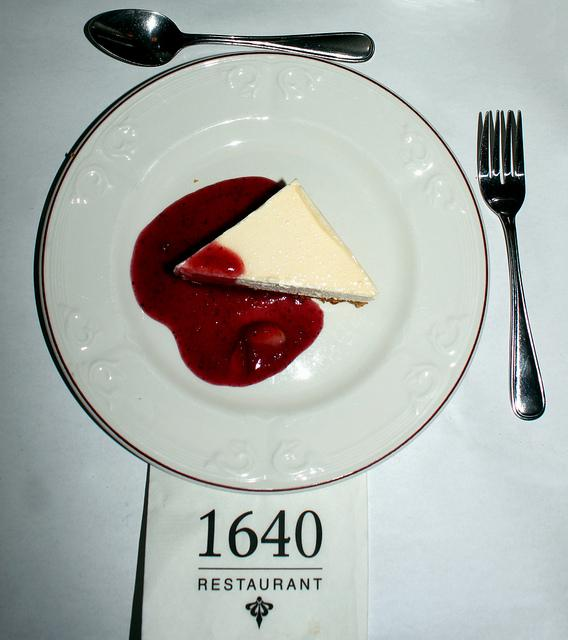What is on the plate? cheesecake 